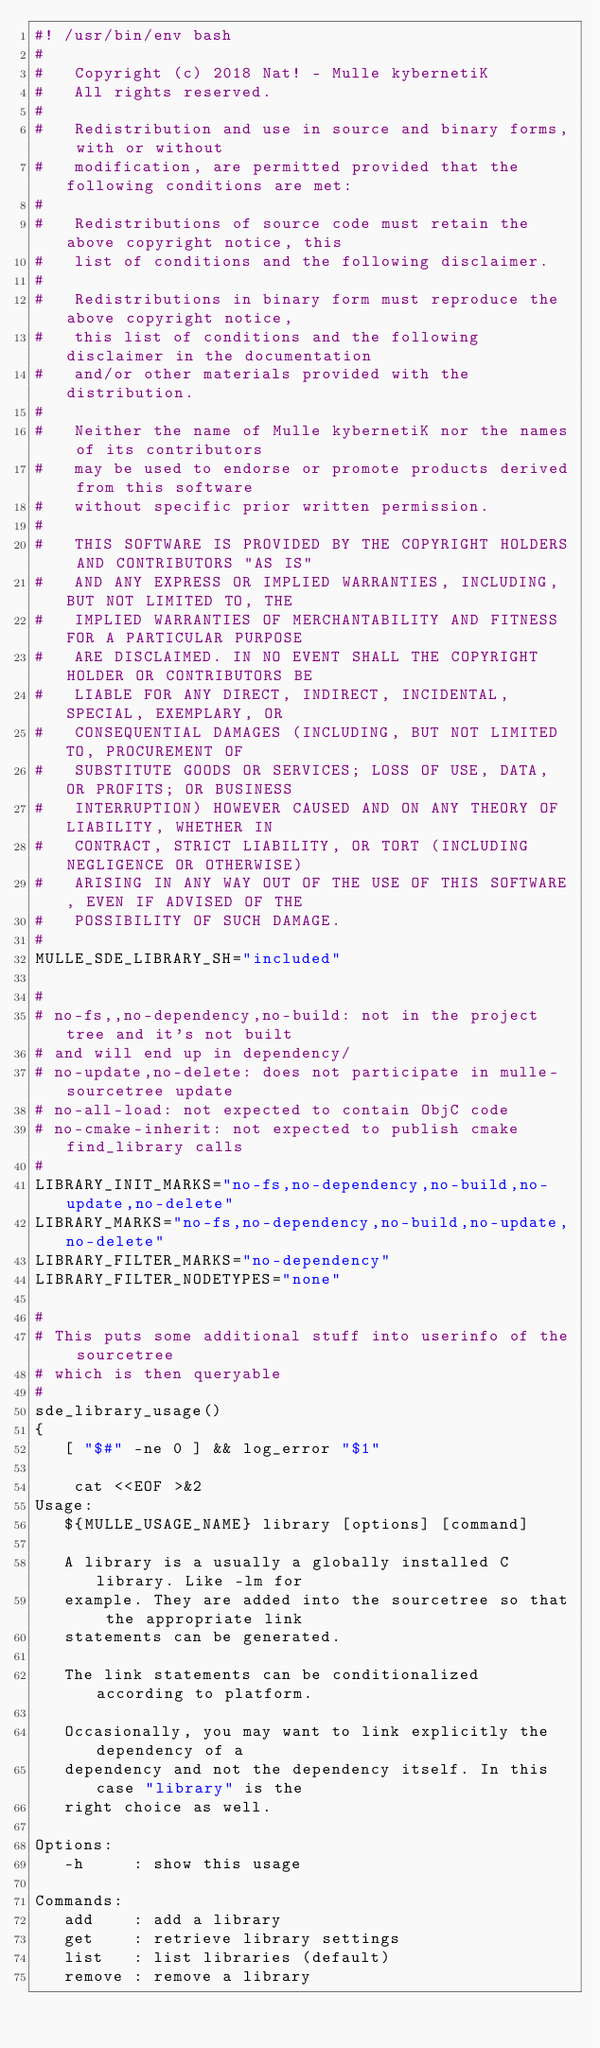Convert code to text. <code><loc_0><loc_0><loc_500><loc_500><_Bash_>#! /usr/bin/env bash
#
#   Copyright (c) 2018 Nat! - Mulle kybernetiK
#   All rights reserved.
#
#   Redistribution and use in source and binary forms, with or without
#   modification, are permitted provided that the following conditions are met:
#
#   Redistributions of source code must retain the above copyright notice, this
#   list of conditions and the following disclaimer.
#
#   Redistributions in binary form must reproduce the above copyright notice,
#   this list of conditions and the following disclaimer in the documentation
#   and/or other materials provided with the distribution.
#
#   Neither the name of Mulle kybernetiK nor the names of its contributors
#   may be used to endorse or promote products derived from this software
#   without specific prior written permission.
#
#   THIS SOFTWARE IS PROVIDED BY THE COPYRIGHT HOLDERS AND CONTRIBUTORS "AS IS"
#   AND ANY EXPRESS OR IMPLIED WARRANTIES, INCLUDING, BUT NOT LIMITED TO, THE
#   IMPLIED WARRANTIES OF MERCHANTABILITY AND FITNESS FOR A PARTICULAR PURPOSE
#   ARE DISCLAIMED. IN NO EVENT SHALL THE COPYRIGHT HOLDER OR CONTRIBUTORS BE
#   LIABLE FOR ANY DIRECT, INDIRECT, INCIDENTAL, SPECIAL, EXEMPLARY, OR
#   CONSEQUENTIAL DAMAGES (INCLUDING, BUT NOT LIMITED TO, PROCUREMENT OF
#   SUBSTITUTE GOODS OR SERVICES; LOSS OF USE, DATA, OR PROFITS; OR BUSINESS
#   INTERRUPTION) HOWEVER CAUSED AND ON ANY THEORY OF LIABILITY, WHETHER IN
#   CONTRACT, STRICT LIABILITY, OR TORT (INCLUDING NEGLIGENCE OR OTHERWISE)
#   ARISING IN ANY WAY OUT OF THE USE OF THIS SOFTWARE, EVEN IF ADVISED OF THE
#   POSSIBILITY OF SUCH DAMAGE.
#
MULLE_SDE_LIBRARY_SH="included"

#
# no-fs,,no-dependency,no-build: not in the project tree and it's not built
# and will end up in dependency/
# no-update,no-delete: does not participate in mulle-sourcetree update
# no-all-load: not expected to contain ObjC code
# no-cmake-inherit: not expected to publish cmake find_library calls
#
LIBRARY_INIT_MARKS="no-fs,no-dependency,no-build,no-update,no-delete"
LIBRARY_MARKS="no-fs,no-dependency,no-build,no-update,no-delete"
LIBRARY_FILTER_MARKS="no-dependency"
LIBRARY_FILTER_NODETYPES="none"

#
# This puts some additional stuff into userinfo of the sourcetree
# which is then queryable
#
sde_library_usage()
{
   [ "$#" -ne 0 ] && log_error "$1"

    cat <<EOF >&2
Usage:
   ${MULLE_USAGE_NAME} library [options] [command]

   A library is a usually a globally installed C library. Like -lm for
   example. They are added into the sourcetree so that the appropriate link
   statements can be generated.

   The link statements can be conditionalized according to platform.

   Occasionally, you may want to link explicitly the dependency of a
   dependency and not the dependency itself. In this case "library" is the
   right choice as well.

Options:
   -h     : show this usage

Commands:
   add    : add a library
   get    : retrieve library settings
   list   : list libraries (default)
   remove : remove a library</code> 